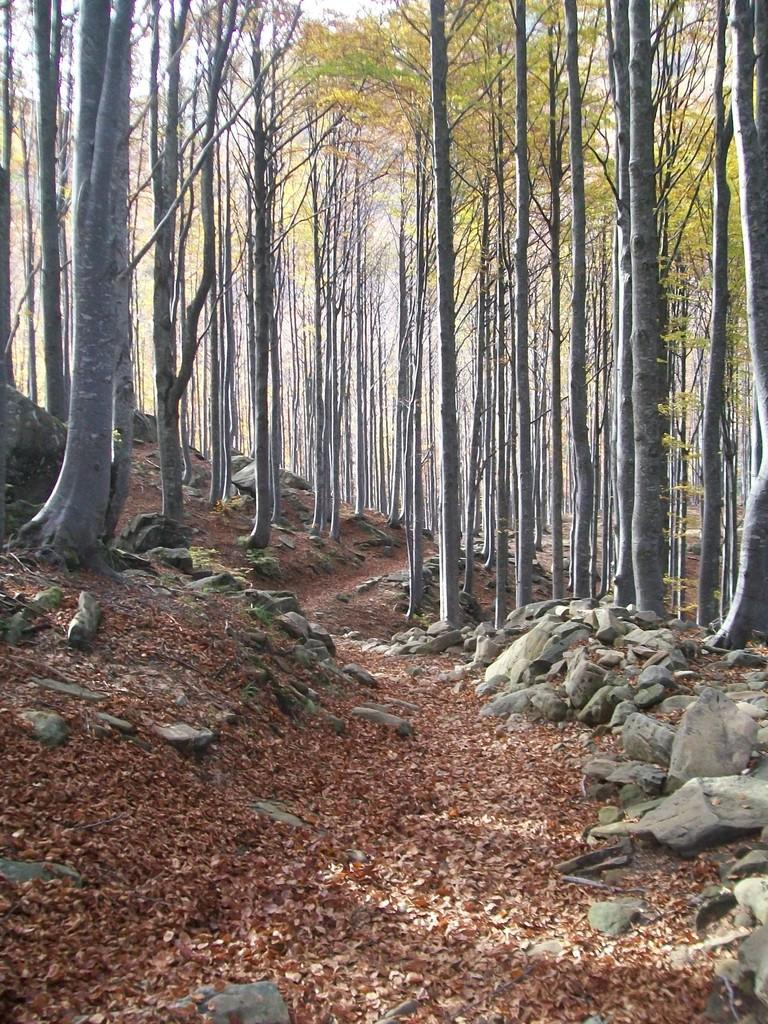What can be seen in the sky in the image? The sky is visible in the image. What type of vegetation is present in the image? There are trees in the image. What type of natural formations can be seen in the image? Rocks and stones are visible in the image. What is on the ground in the image? Shredded leaves are on the ground in the image. Can you tell me how many knees are visible in the image? There are no knees present in the image. What type of shock can be seen in the image? There is no shock present in the image. 